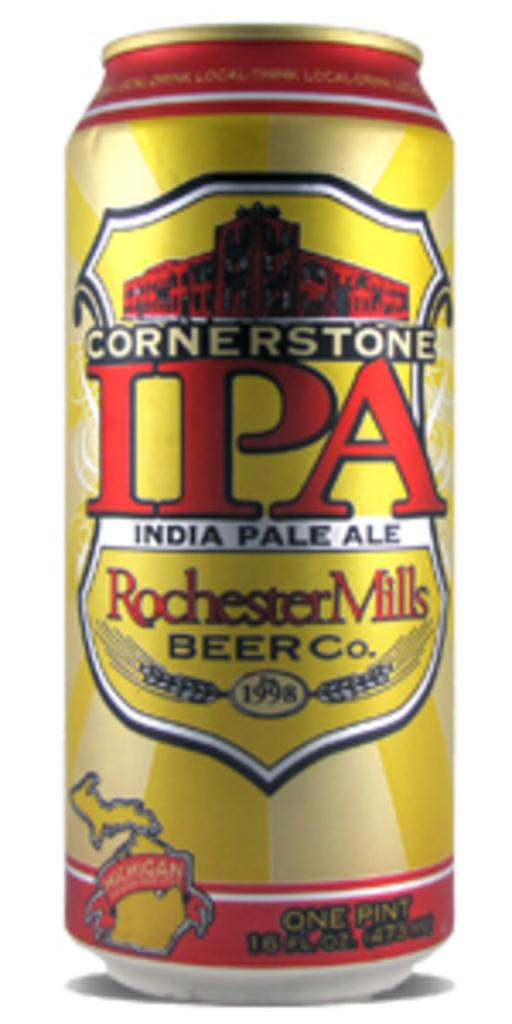<image>
Relay a brief, clear account of the picture shown. a can that says Rochester Mills on it 